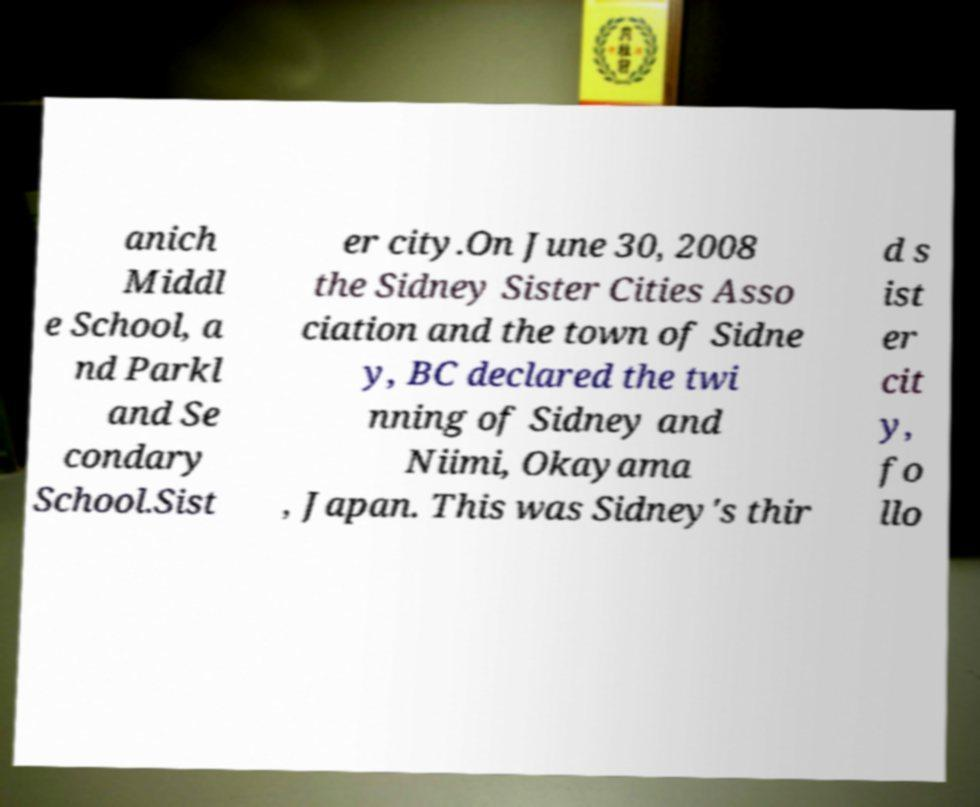Please read and relay the text visible in this image. What does it say? anich Middl e School, a nd Parkl and Se condary School.Sist er city.On June 30, 2008 the Sidney Sister Cities Asso ciation and the town of Sidne y, BC declared the twi nning of Sidney and Niimi, Okayama , Japan. This was Sidney's thir d s ist er cit y, fo llo 